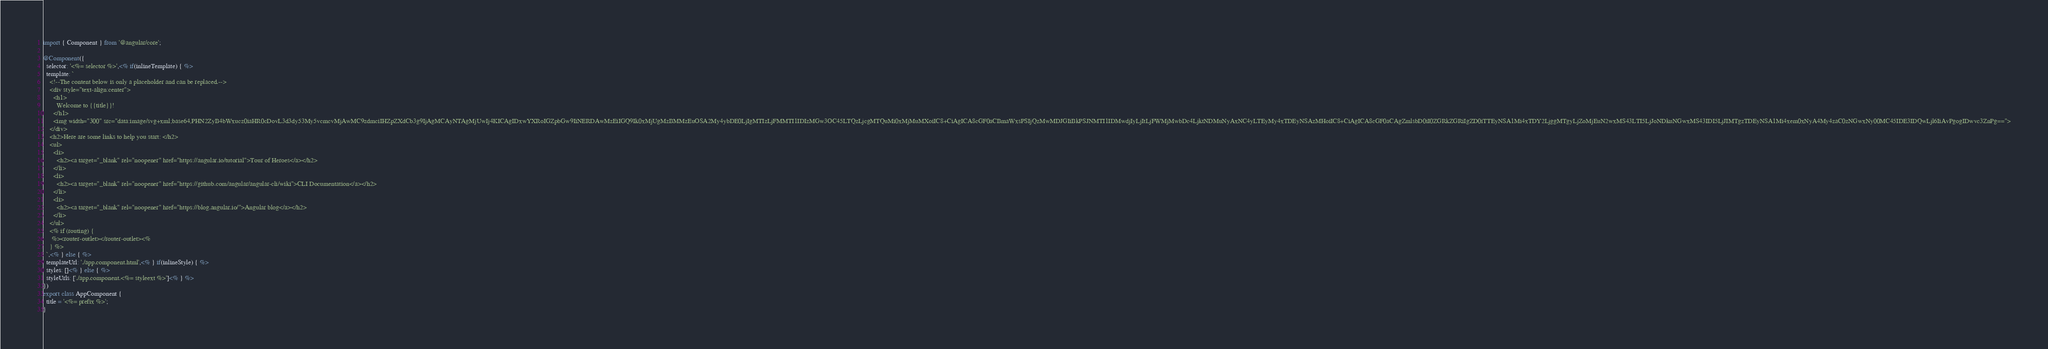<code> <loc_0><loc_0><loc_500><loc_500><_TypeScript_>import { Component } from '@angular/core';

@Component({
  selector: '<%= selector %>',<% if(inlineTemplate) { %>
  template: `
    <!--The content below is only a placeholder and can be replaced.-->
    <div style="text-align:center">
      <h1>
        Welcome to {{title}}!
      </h1>
      <img width="300" src="data:image/svg+xml;base64,PHN2ZyB4bWxucz0iaHR0cDovL3d3dy53My5vcmcvMjAwMC9zdmciIHZpZXdCb3g9IjAgMCAyNTAgMjUwIj4KICAgIDxwYXRoIGZpbGw9IiNERDAwMzEiIGQ9Ik0xMjUgMzBMMzEuOSA2My4ybDE0LjIgMTIzLjFMMTI1IDIzMGw3OC45LTQzLjcgMTQuMi0xMjMuMXoiIC8+CiAgICA8cGF0aCBmaWxsPSIjQzMwMDJGIiBkPSJNMTI1IDMwdjIyLjItLjFWMjMwbDc4LjktNDMuNyAxNC4yLTEyMy4xTDEyNSAzMHoiIC8+CiAgICA8cGF0aCAgZmlsbD0iI0ZGRkZGRiIgZD0iTTEyNSA1Mi4xTDY2LjggMTgyLjZoMjEuN2wxMS43LTI5LjJoNDkuNGwxMS43IDI5LjJIMTgzTDEyNSA1Mi4xem0xNyA4My4zaC0zNGwxNy00MC45IDE3IDQwLjl6IiAvPgogIDwvc3ZnPg==">
    </div>
    <h2>Here are some links to help you start: </h2>
    <ul>
      <li>
        <h2><a target="_blank" rel="noopener" href="https://angular.io/tutorial">Tour of Heroes</a></h2>
      </li>
      <li>
        <h2><a target="_blank" rel="noopener" href="https://github.com/angular/angular-cli/wiki">CLI Documentation</a></h2>
      </li>
      <li>
        <h2><a target="_blank" rel="noopener" href="https://blog.angular.io/">Angular blog</a></h2>
      </li>
    </ul>
    <% if (routing) {
     %><router-outlet></router-outlet><%
    } %>
  `,<% } else { %>
  templateUrl: './app.component.html',<% } if(inlineStyle) { %>
  styles: []<% } else { %>
  styleUrls: ['./app.component.<%= styleext %>']<% } %>
})
export class AppComponent {
  title = '<%= prefix %>';
}
</code> 